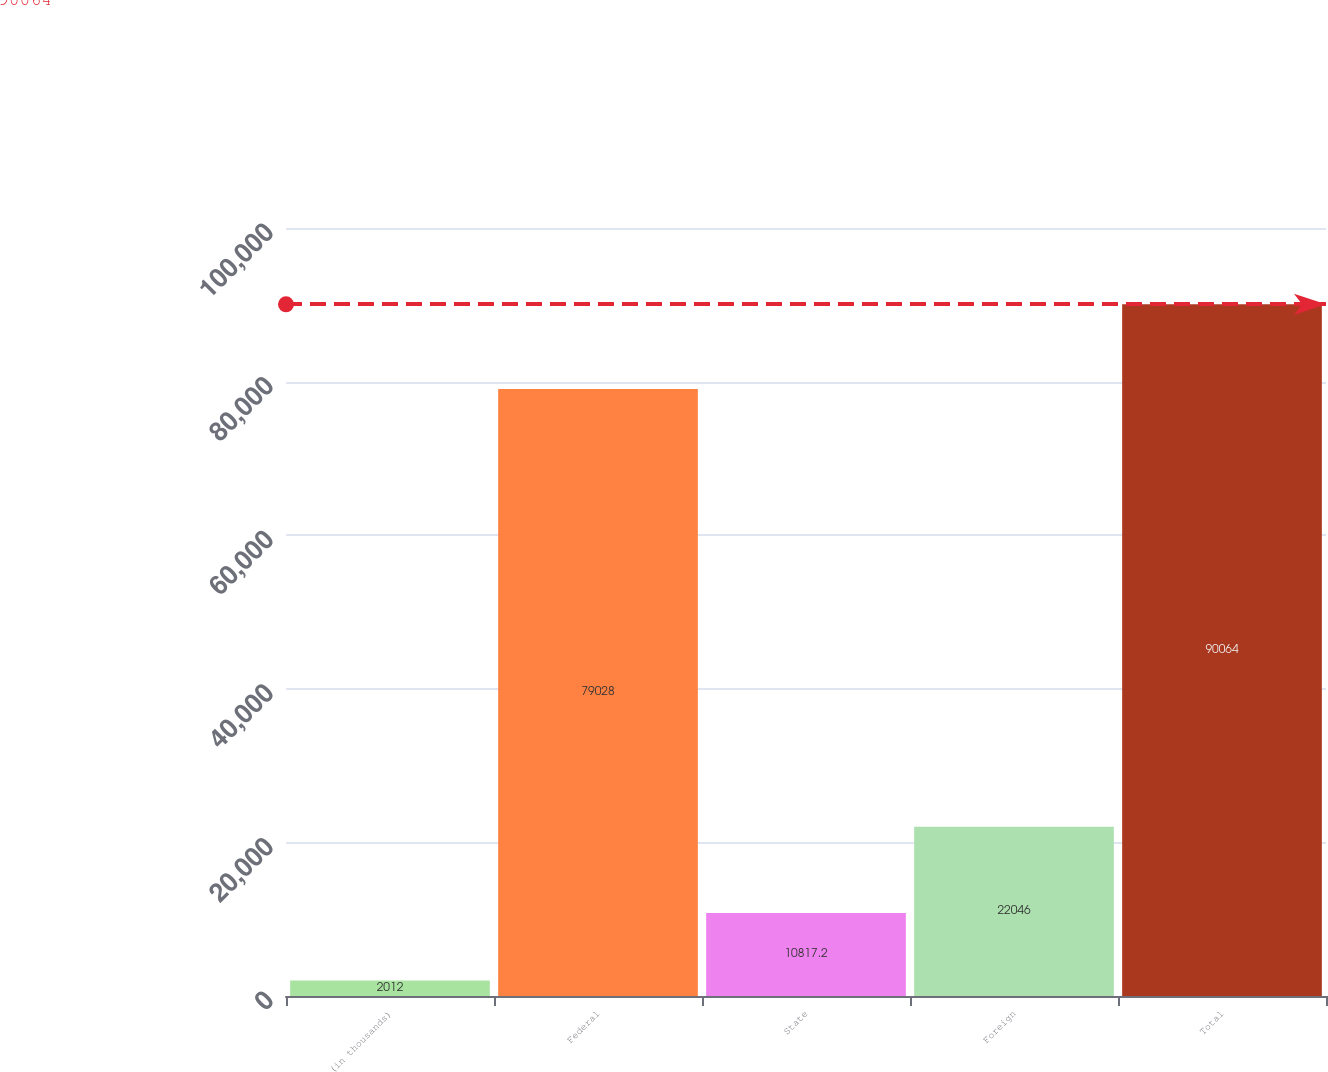Convert chart. <chart><loc_0><loc_0><loc_500><loc_500><bar_chart><fcel>(in thousands)<fcel>Federal<fcel>State<fcel>Foreign<fcel>Total<nl><fcel>2012<fcel>79028<fcel>10817.2<fcel>22046<fcel>90064<nl></chart> 